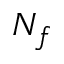Convert formula to latex. <formula><loc_0><loc_0><loc_500><loc_500>N _ { f }</formula> 